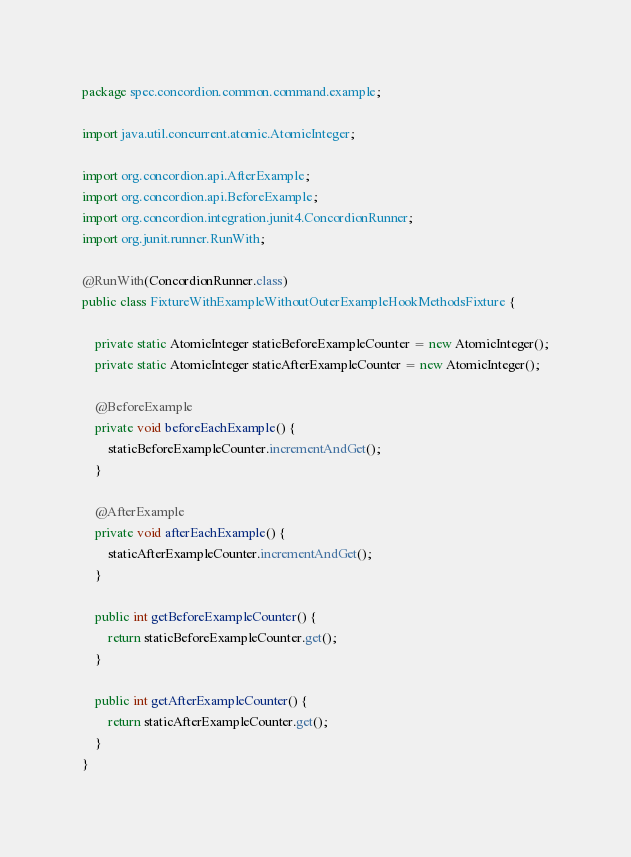<code> <loc_0><loc_0><loc_500><loc_500><_Java_>package spec.concordion.common.command.example;

import java.util.concurrent.atomic.AtomicInteger;

import org.concordion.api.AfterExample;
import org.concordion.api.BeforeExample;
import org.concordion.integration.junit4.ConcordionRunner;
import org.junit.runner.RunWith;

@RunWith(ConcordionRunner.class)
public class FixtureWithExampleWithoutOuterExampleHookMethodsFixture {

    private static AtomicInteger staticBeforeExampleCounter = new AtomicInteger();
    private static AtomicInteger staticAfterExampleCounter = new AtomicInteger();
    
    @BeforeExample
    private void beforeEachExample() {
        staticBeforeExampleCounter.incrementAndGet();
    }
    
    @AfterExample
    private void afterEachExample() {
        staticAfterExampleCounter.incrementAndGet();
    }
    
    public int getBeforeExampleCounter() {
        return staticBeforeExampleCounter.get();
    }

    public int getAfterExampleCounter() {
        return staticAfterExampleCounter.get();
    }
}
</code> 